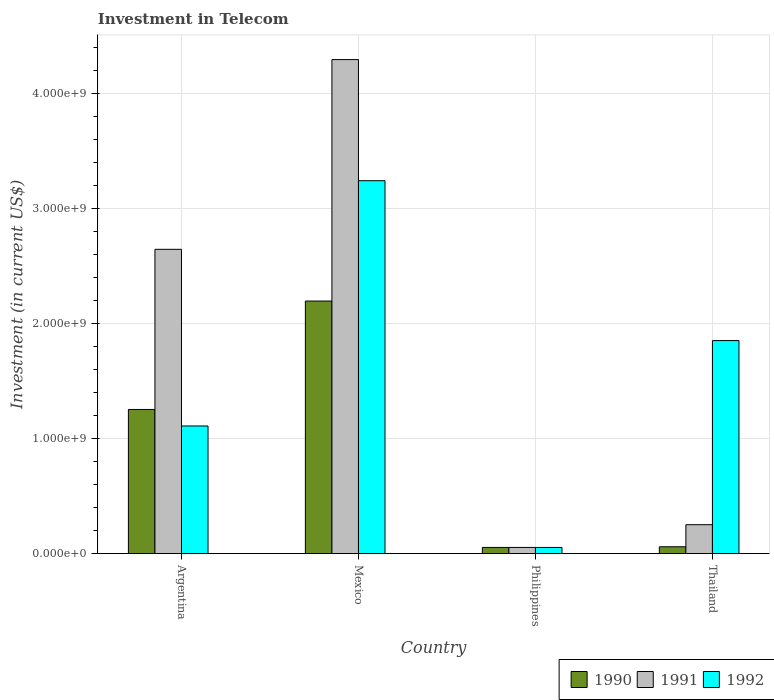How many groups of bars are there?
Your answer should be very brief. 4. Are the number of bars per tick equal to the number of legend labels?
Your response must be concise. Yes. Are the number of bars on each tick of the X-axis equal?
Your response must be concise. Yes. How many bars are there on the 3rd tick from the left?
Provide a short and direct response. 3. What is the amount invested in telecom in 1990 in Philippines?
Your answer should be compact. 5.42e+07. Across all countries, what is the maximum amount invested in telecom in 1991?
Provide a succinct answer. 4.30e+09. Across all countries, what is the minimum amount invested in telecom in 1992?
Ensure brevity in your answer.  5.42e+07. In which country was the amount invested in telecom in 1992 maximum?
Offer a terse response. Mexico. In which country was the amount invested in telecom in 1990 minimum?
Your answer should be very brief. Philippines. What is the total amount invested in telecom in 1991 in the graph?
Your answer should be very brief. 7.25e+09. What is the difference between the amount invested in telecom in 1991 in Philippines and that in Thailand?
Your response must be concise. -1.98e+08. What is the difference between the amount invested in telecom in 1992 in Argentina and the amount invested in telecom in 1991 in Thailand?
Make the answer very short. 8.59e+08. What is the average amount invested in telecom in 1991 per country?
Provide a succinct answer. 1.81e+09. What is the difference between the amount invested in telecom of/in 1991 and amount invested in telecom of/in 1990 in Mexico?
Provide a short and direct response. 2.10e+09. In how many countries, is the amount invested in telecom in 1991 greater than 2000000000 US$?
Provide a short and direct response. 2. What is the ratio of the amount invested in telecom in 1992 in Mexico to that in Thailand?
Your response must be concise. 1.75. What is the difference between the highest and the second highest amount invested in telecom in 1992?
Keep it short and to the point. 1.39e+09. What is the difference between the highest and the lowest amount invested in telecom in 1992?
Keep it short and to the point. 3.19e+09. Is the sum of the amount invested in telecom in 1992 in Argentina and Thailand greater than the maximum amount invested in telecom in 1990 across all countries?
Provide a short and direct response. Yes. How many countries are there in the graph?
Your response must be concise. 4. What is the difference between two consecutive major ticks on the Y-axis?
Ensure brevity in your answer.  1.00e+09. Are the values on the major ticks of Y-axis written in scientific E-notation?
Keep it short and to the point. Yes. Does the graph contain grids?
Offer a terse response. Yes. Where does the legend appear in the graph?
Give a very brief answer. Bottom right. How many legend labels are there?
Provide a short and direct response. 3. How are the legend labels stacked?
Offer a very short reply. Horizontal. What is the title of the graph?
Your answer should be very brief. Investment in Telecom. Does "1986" appear as one of the legend labels in the graph?
Your answer should be very brief. No. What is the label or title of the Y-axis?
Your answer should be very brief. Investment (in current US$). What is the Investment (in current US$) of 1990 in Argentina?
Offer a very short reply. 1.25e+09. What is the Investment (in current US$) in 1991 in Argentina?
Provide a succinct answer. 2.65e+09. What is the Investment (in current US$) of 1992 in Argentina?
Offer a terse response. 1.11e+09. What is the Investment (in current US$) in 1990 in Mexico?
Ensure brevity in your answer.  2.20e+09. What is the Investment (in current US$) in 1991 in Mexico?
Provide a succinct answer. 4.30e+09. What is the Investment (in current US$) of 1992 in Mexico?
Keep it short and to the point. 3.24e+09. What is the Investment (in current US$) of 1990 in Philippines?
Offer a terse response. 5.42e+07. What is the Investment (in current US$) in 1991 in Philippines?
Provide a short and direct response. 5.42e+07. What is the Investment (in current US$) of 1992 in Philippines?
Give a very brief answer. 5.42e+07. What is the Investment (in current US$) in 1990 in Thailand?
Give a very brief answer. 6.00e+07. What is the Investment (in current US$) of 1991 in Thailand?
Offer a very short reply. 2.52e+08. What is the Investment (in current US$) in 1992 in Thailand?
Keep it short and to the point. 1.85e+09. Across all countries, what is the maximum Investment (in current US$) in 1990?
Your response must be concise. 2.20e+09. Across all countries, what is the maximum Investment (in current US$) of 1991?
Provide a short and direct response. 4.30e+09. Across all countries, what is the maximum Investment (in current US$) in 1992?
Ensure brevity in your answer.  3.24e+09. Across all countries, what is the minimum Investment (in current US$) of 1990?
Ensure brevity in your answer.  5.42e+07. Across all countries, what is the minimum Investment (in current US$) in 1991?
Ensure brevity in your answer.  5.42e+07. Across all countries, what is the minimum Investment (in current US$) of 1992?
Your response must be concise. 5.42e+07. What is the total Investment (in current US$) in 1990 in the graph?
Provide a succinct answer. 3.57e+09. What is the total Investment (in current US$) in 1991 in the graph?
Provide a succinct answer. 7.25e+09. What is the total Investment (in current US$) in 1992 in the graph?
Your answer should be compact. 6.26e+09. What is the difference between the Investment (in current US$) of 1990 in Argentina and that in Mexico?
Your response must be concise. -9.43e+08. What is the difference between the Investment (in current US$) in 1991 in Argentina and that in Mexico?
Your answer should be very brief. -1.65e+09. What is the difference between the Investment (in current US$) of 1992 in Argentina and that in Mexico?
Provide a short and direct response. -2.13e+09. What is the difference between the Investment (in current US$) of 1990 in Argentina and that in Philippines?
Your answer should be very brief. 1.20e+09. What is the difference between the Investment (in current US$) of 1991 in Argentina and that in Philippines?
Your response must be concise. 2.59e+09. What is the difference between the Investment (in current US$) in 1992 in Argentina and that in Philippines?
Ensure brevity in your answer.  1.06e+09. What is the difference between the Investment (in current US$) in 1990 in Argentina and that in Thailand?
Provide a succinct answer. 1.19e+09. What is the difference between the Investment (in current US$) in 1991 in Argentina and that in Thailand?
Make the answer very short. 2.40e+09. What is the difference between the Investment (in current US$) in 1992 in Argentina and that in Thailand?
Your answer should be compact. -7.43e+08. What is the difference between the Investment (in current US$) of 1990 in Mexico and that in Philippines?
Make the answer very short. 2.14e+09. What is the difference between the Investment (in current US$) of 1991 in Mexico and that in Philippines?
Your response must be concise. 4.24e+09. What is the difference between the Investment (in current US$) of 1992 in Mexico and that in Philippines?
Ensure brevity in your answer.  3.19e+09. What is the difference between the Investment (in current US$) in 1990 in Mexico and that in Thailand?
Give a very brief answer. 2.14e+09. What is the difference between the Investment (in current US$) in 1991 in Mexico and that in Thailand?
Make the answer very short. 4.05e+09. What is the difference between the Investment (in current US$) of 1992 in Mexico and that in Thailand?
Provide a short and direct response. 1.39e+09. What is the difference between the Investment (in current US$) in 1990 in Philippines and that in Thailand?
Keep it short and to the point. -5.80e+06. What is the difference between the Investment (in current US$) in 1991 in Philippines and that in Thailand?
Offer a terse response. -1.98e+08. What is the difference between the Investment (in current US$) in 1992 in Philippines and that in Thailand?
Offer a very short reply. -1.80e+09. What is the difference between the Investment (in current US$) of 1990 in Argentina and the Investment (in current US$) of 1991 in Mexico?
Offer a terse response. -3.04e+09. What is the difference between the Investment (in current US$) in 1990 in Argentina and the Investment (in current US$) in 1992 in Mexico?
Offer a terse response. -1.99e+09. What is the difference between the Investment (in current US$) in 1991 in Argentina and the Investment (in current US$) in 1992 in Mexico?
Offer a very short reply. -5.97e+08. What is the difference between the Investment (in current US$) of 1990 in Argentina and the Investment (in current US$) of 1991 in Philippines?
Ensure brevity in your answer.  1.20e+09. What is the difference between the Investment (in current US$) of 1990 in Argentina and the Investment (in current US$) of 1992 in Philippines?
Offer a very short reply. 1.20e+09. What is the difference between the Investment (in current US$) of 1991 in Argentina and the Investment (in current US$) of 1992 in Philippines?
Provide a succinct answer. 2.59e+09. What is the difference between the Investment (in current US$) in 1990 in Argentina and the Investment (in current US$) in 1991 in Thailand?
Give a very brief answer. 1.00e+09. What is the difference between the Investment (in current US$) in 1990 in Argentina and the Investment (in current US$) in 1992 in Thailand?
Make the answer very short. -5.99e+08. What is the difference between the Investment (in current US$) in 1991 in Argentina and the Investment (in current US$) in 1992 in Thailand?
Provide a succinct answer. 7.94e+08. What is the difference between the Investment (in current US$) of 1990 in Mexico and the Investment (in current US$) of 1991 in Philippines?
Make the answer very short. 2.14e+09. What is the difference between the Investment (in current US$) in 1990 in Mexico and the Investment (in current US$) in 1992 in Philippines?
Provide a short and direct response. 2.14e+09. What is the difference between the Investment (in current US$) in 1991 in Mexico and the Investment (in current US$) in 1992 in Philippines?
Provide a succinct answer. 4.24e+09. What is the difference between the Investment (in current US$) of 1990 in Mexico and the Investment (in current US$) of 1991 in Thailand?
Give a very brief answer. 1.95e+09. What is the difference between the Investment (in current US$) of 1990 in Mexico and the Investment (in current US$) of 1992 in Thailand?
Your answer should be very brief. 3.44e+08. What is the difference between the Investment (in current US$) of 1991 in Mexico and the Investment (in current US$) of 1992 in Thailand?
Give a very brief answer. 2.44e+09. What is the difference between the Investment (in current US$) in 1990 in Philippines and the Investment (in current US$) in 1991 in Thailand?
Make the answer very short. -1.98e+08. What is the difference between the Investment (in current US$) of 1990 in Philippines and the Investment (in current US$) of 1992 in Thailand?
Give a very brief answer. -1.80e+09. What is the difference between the Investment (in current US$) of 1991 in Philippines and the Investment (in current US$) of 1992 in Thailand?
Your answer should be compact. -1.80e+09. What is the average Investment (in current US$) of 1990 per country?
Your response must be concise. 8.92e+08. What is the average Investment (in current US$) of 1991 per country?
Your answer should be compact. 1.81e+09. What is the average Investment (in current US$) in 1992 per country?
Offer a terse response. 1.57e+09. What is the difference between the Investment (in current US$) in 1990 and Investment (in current US$) in 1991 in Argentina?
Ensure brevity in your answer.  -1.39e+09. What is the difference between the Investment (in current US$) of 1990 and Investment (in current US$) of 1992 in Argentina?
Ensure brevity in your answer.  1.44e+08. What is the difference between the Investment (in current US$) of 1991 and Investment (in current US$) of 1992 in Argentina?
Offer a very short reply. 1.54e+09. What is the difference between the Investment (in current US$) of 1990 and Investment (in current US$) of 1991 in Mexico?
Your answer should be compact. -2.10e+09. What is the difference between the Investment (in current US$) in 1990 and Investment (in current US$) in 1992 in Mexico?
Offer a very short reply. -1.05e+09. What is the difference between the Investment (in current US$) of 1991 and Investment (in current US$) of 1992 in Mexico?
Provide a succinct answer. 1.05e+09. What is the difference between the Investment (in current US$) of 1990 and Investment (in current US$) of 1992 in Philippines?
Your response must be concise. 0. What is the difference between the Investment (in current US$) in 1991 and Investment (in current US$) in 1992 in Philippines?
Ensure brevity in your answer.  0. What is the difference between the Investment (in current US$) of 1990 and Investment (in current US$) of 1991 in Thailand?
Your answer should be compact. -1.92e+08. What is the difference between the Investment (in current US$) of 1990 and Investment (in current US$) of 1992 in Thailand?
Keep it short and to the point. -1.79e+09. What is the difference between the Investment (in current US$) in 1991 and Investment (in current US$) in 1992 in Thailand?
Your response must be concise. -1.60e+09. What is the ratio of the Investment (in current US$) in 1990 in Argentina to that in Mexico?
Your answer should be compact. 0.57. What is the ratio of the Investment (in current US$) in 1991 in Argentina to that in Mexico?
Your response must be concise. 0.62. What is the ratio of the Investment (in current US$) of 1992 in Argentina to that in Mexico?
Offer a very short reply. 0.34. What is the ratio of the Investment (in current US$) of 1990 in Argentina to that in Philippines?
Your response must be concise. 23.15. What is the ratio of the Investment (in current US$) of 1991 in Argentina to that in Philippines?
Offer a terse response. 48.86. What is the ratio of the Investment (in current US$) of 1992 in Argentina to that in Philippines?
Keep it short and to the point. 20.5. What is the ratio of the Investment (in current US$) of 1990 in Argentina to that in Thailand?
Keep it short and to the point. 20.91. What is the ratio of the Investment (in current US$) in 1991 in Argentina to that in Thailand?
Make the answer very short. 10.51. What is the ratio of the Investment (in current US$) in 1992 in Argentina to that in Thailand?
Your answer should be compact. 0.6. What is the ratio of the Investment (in current US$) in 1990 in Mexico to that in Philippines?
Your answer should be very brief. 40.55. What is the ratio of the Investment (in current US$) of 1991 in Mexico to that in Philippines?
Your answer should be very brief. 79.32. What is the ratio of the Investment (in current US$) of 1992 in Mexico to that in Philippines?
Your response must be concise. 59.87. What is the ratio of the Investment (in current US$) in 1990 in Mexico to that in Thailand?
Offer a terse response. 36.63. What is the ratio of the Investment (in current US$) in 1991 in Mexico to that in Thailand?
Your answer should be compact. 17.06. What is the ratio of the Investment (in current US$) in 1992 in Mexico to that in Thailand?
Provide a short and direct response. 1.75. What is the ratio of the Investment (in current US$) in 1990 in Philippines to that in Thailand?
Your answer should be compact. 0.9. What is the ratio of the Investment (in current US$) in 1991 in Philippines to that in Thailand?
Keep it short and to the point. 0.22. What is the ratio of the Investment (in current US$) in 1992 in Philippines to that in Thailand?
Ensure brevity in your answer.  0.03. What is the difference between the highest and the second highest Investment (in current US$) in 1990?
Your response must be concise. 9.43e+08. What is the difference between the highest and the second highest Investment (in current US$) of 1991?
Offer a very short reply. 1.65e+09. What is the difference between the highest and the second highest Investment (in current US$) of 1992?
Your answer should be compact. 1.39e+09. What is the difference between the highest and the lowest Investment (in current US$) in 1990?
Make the answer very short. 2.14e+09. What is the difference between the highest and the lowest Investment (in current US$) in 1991?
Your answer should be compact. 4.24e+09. What is the difference between the highest and the lowest Investment (in current US$) in 1992?
Make the answer very short. 3.19e+09. 